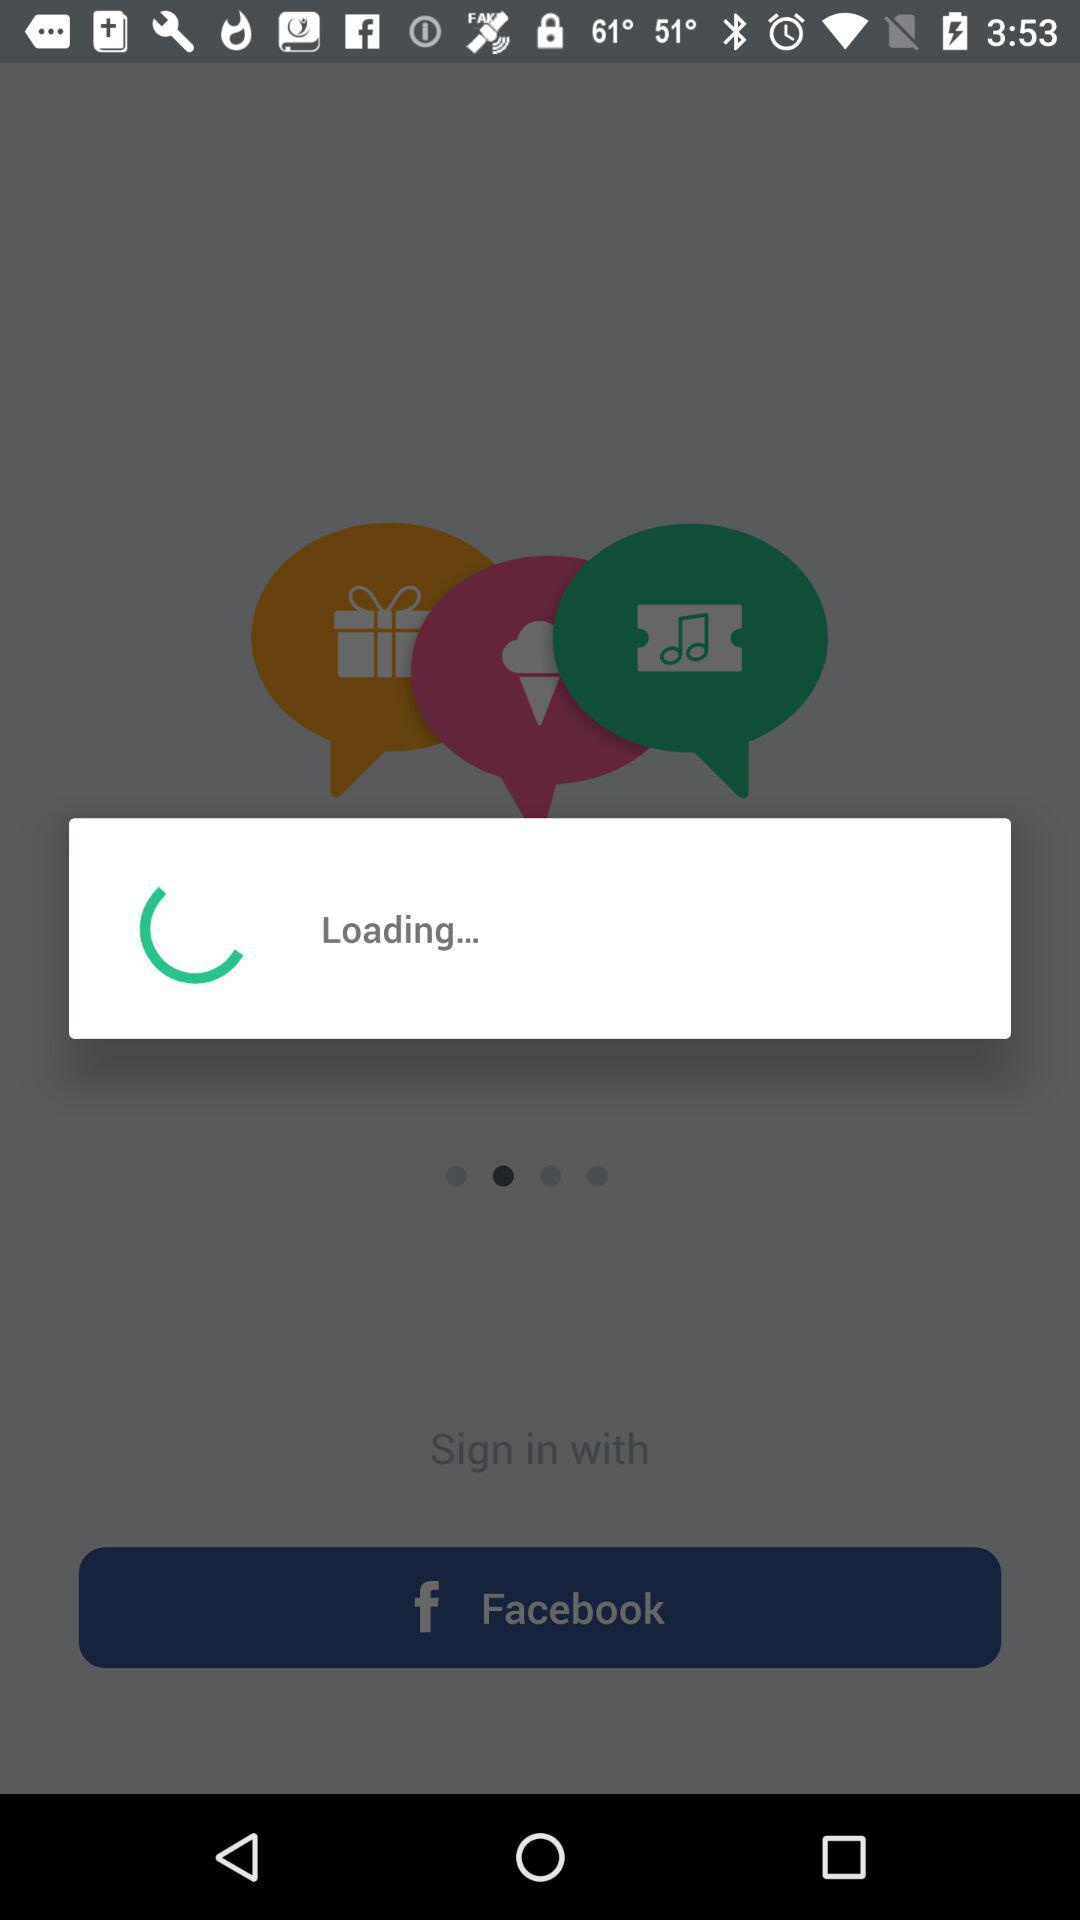Who will receive the public profile? The public profile will be received by "Prince". 